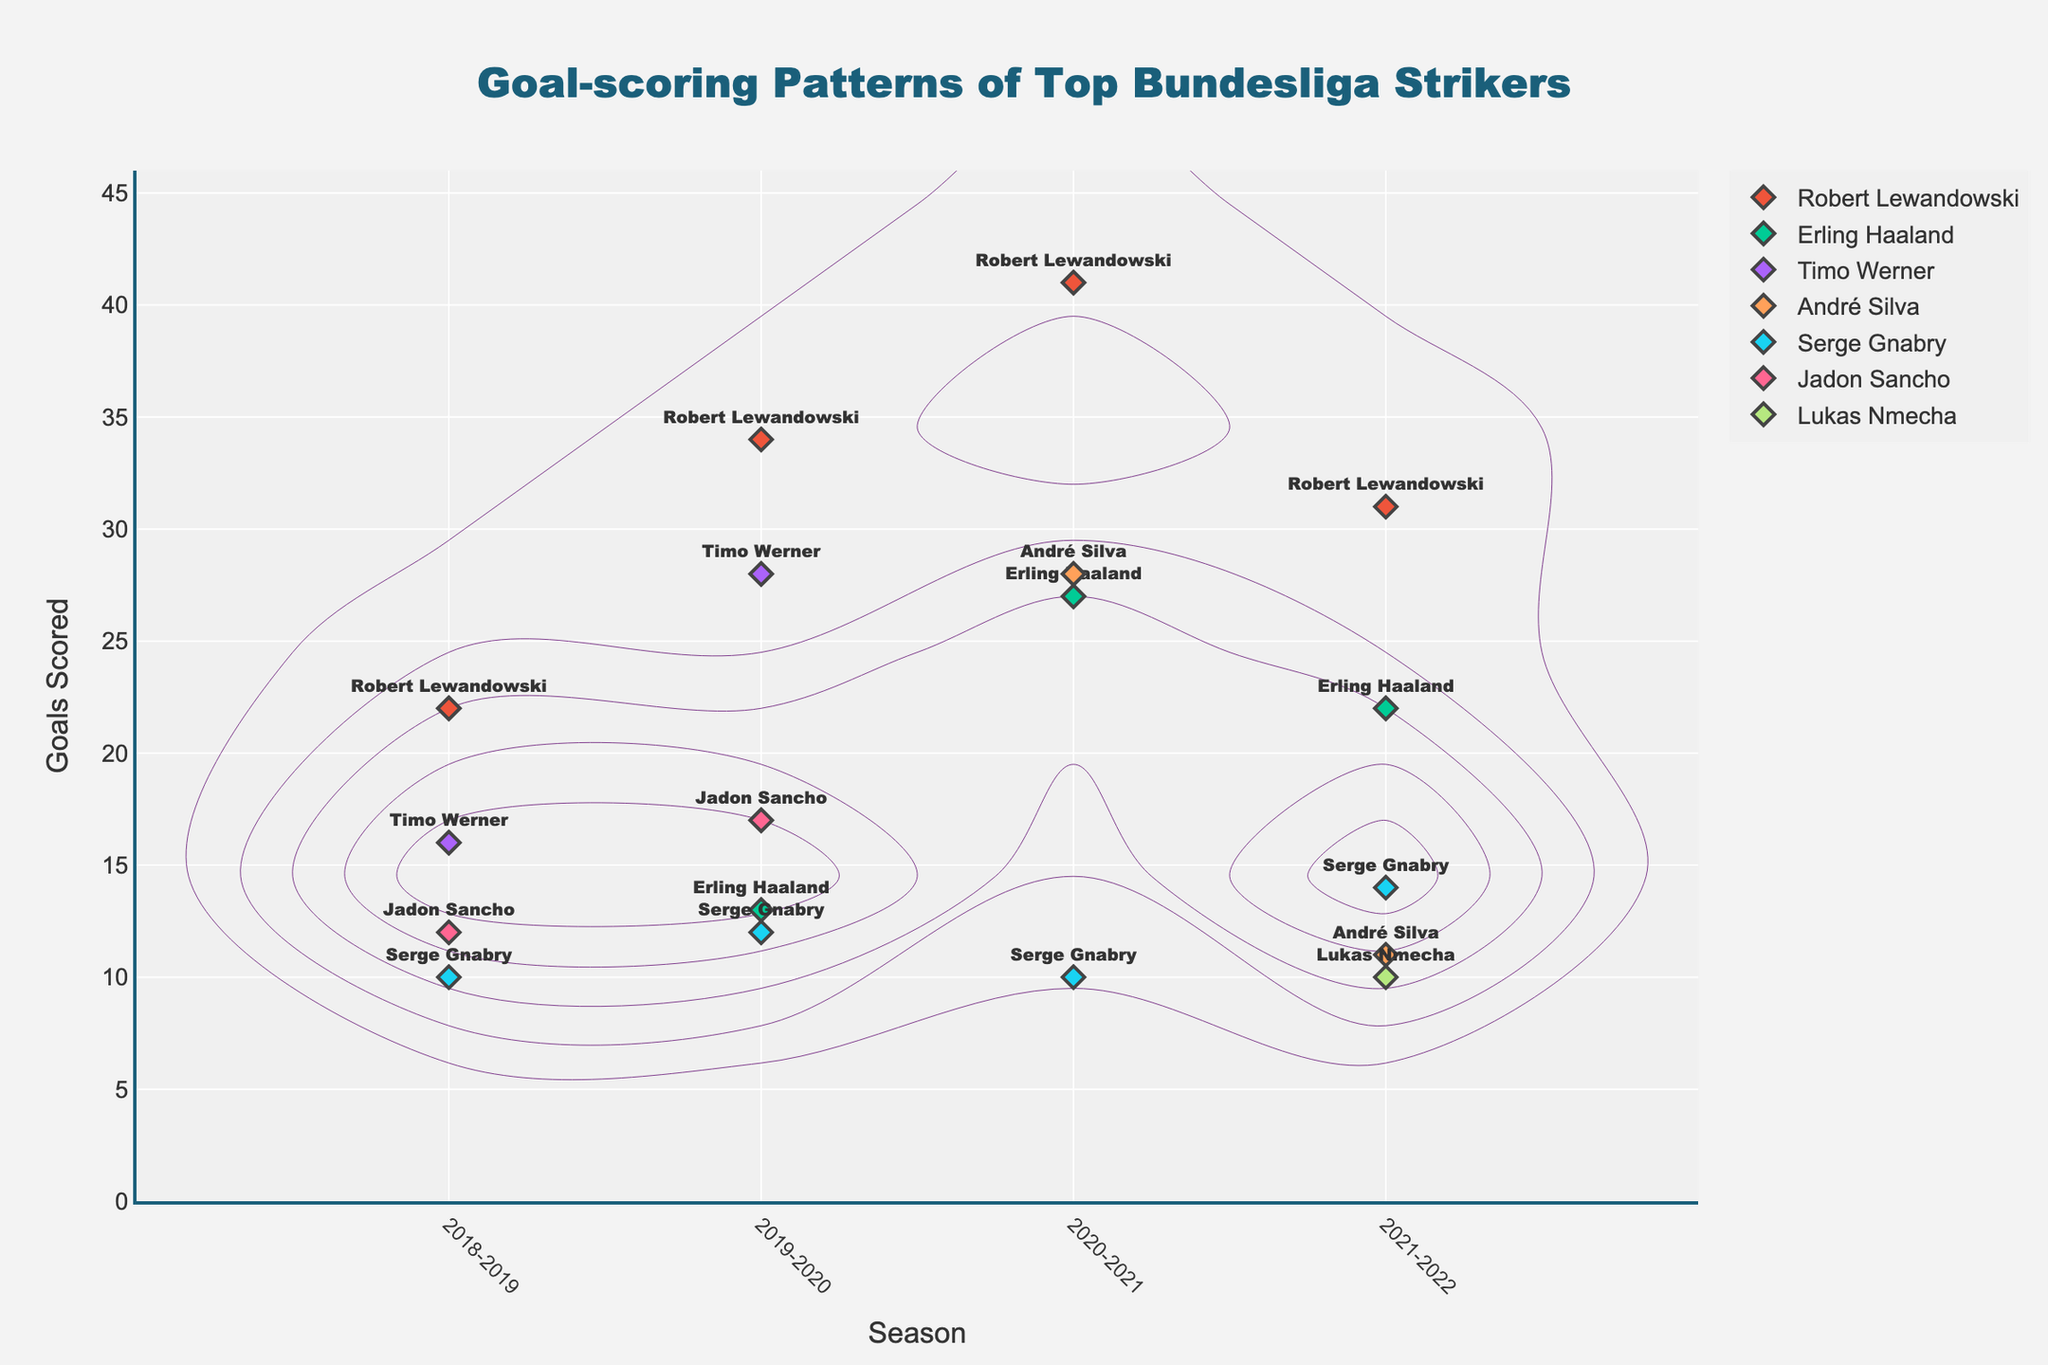What is the title of the figure? The title of the figure is prominently displayed at the top and reads "Goal-scoring Patterns of Top Bundesliga Strikers".
Answer: Goal-scoring Patterns of Top Bundesliga Strikers What is the range of seasons shown on the x-axis? The x-axis labels indicate the different seasons, ranging chronologically starting from "2018-2019" to "2021-2022".
Answer: 2018-2019 to 2021-2022 How many goals did Robert Lewandowski score in the 2020-2021 season? By observing the data points labeled with player names, Robert Lewandowski's goal count for the 2020-2021 season is shown as 41.
Answer: 41 Which player had the highest number of goals scored in a single season? Robert Lewandowski scored the highest number of goals in a single season with 41 goals in the 2020-2021 season, indicated by the relevant data point on the plot.
Answer: Robert Lewandowski Comparing the 2019-2020 seasons, who scored more goals: Robert Lewandowski or Erling Haaland? The plot shows Robert Lewandowski with 34 goals and Erling Haaland with 13 goals in the 2019-2020 season. Thus, Robert Lewandowski scored more goals.
Answer: Robert Lewandowski How does Timo Werner's goal-scoring trend compare between the 2018-2019 and 2019-2020 seasons? By comparing Timo Werner's data points, he scored 16 goals in 2018-2019 and increased to 28 goals in the 2019-2020 season. This shows an upward trend in goal-scoring.
Answer: Increased Identify a season where two players had the same number of goals, and name the players. Observing the plot, in the 2021-2022 season, both Erling Haaland and Robert Lewandowski scored 22 goals each.
Answer: Erling Haaland and Robert Lewandowski What was the total goal count for Serge Gnabry across all seasons shown? Serge Gnabry’s goals across the seasons are 10 (2018-2019), 12 (2019-2020), 10 (2020-2021), and 14 (2021-2022). Adding these gives a total of 46 goals.
Answer: 46 Who shows the widest variation in goal-scoring across different seasons? Robert Lewandowski shows a wide variation with goals ranging from 22 to 41 across different seasons, indicating a significant fluctuation.
Answer: Robert Lewandowski 